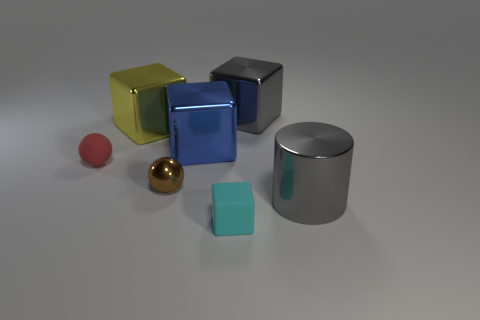Add 2 big yellow things. How many objects exist? 9 Subtract all cubes. How many objects are left? 3 Subtract all yellow matte spheres. Subtract all small brown things. How many objects are left? 6 Add 5 big cylinders. How many big cylinders are left? 6 Add 5 big brown metal balls. How many big brown metal balls exist? 5 Subtract 0 green balls. How many objects are left? 7 